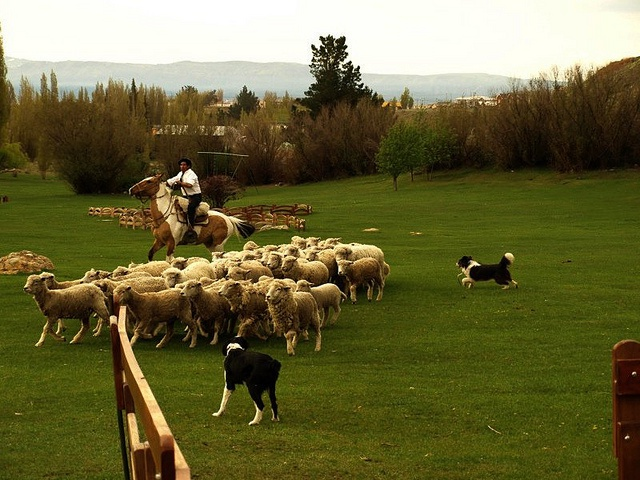Describe the objects in this image and their specific colors. I can see sheep in ivory, black, khaki, olive, and tan tones, horse in ivory, black, maroon, olive, and tan tones, dog in ivory, black, darkgreen, tan, and khaki tones, sheep in ivory, black, olive, and maroon tones, and sheep in ivory, black, maroon, and olive tones in this image. 